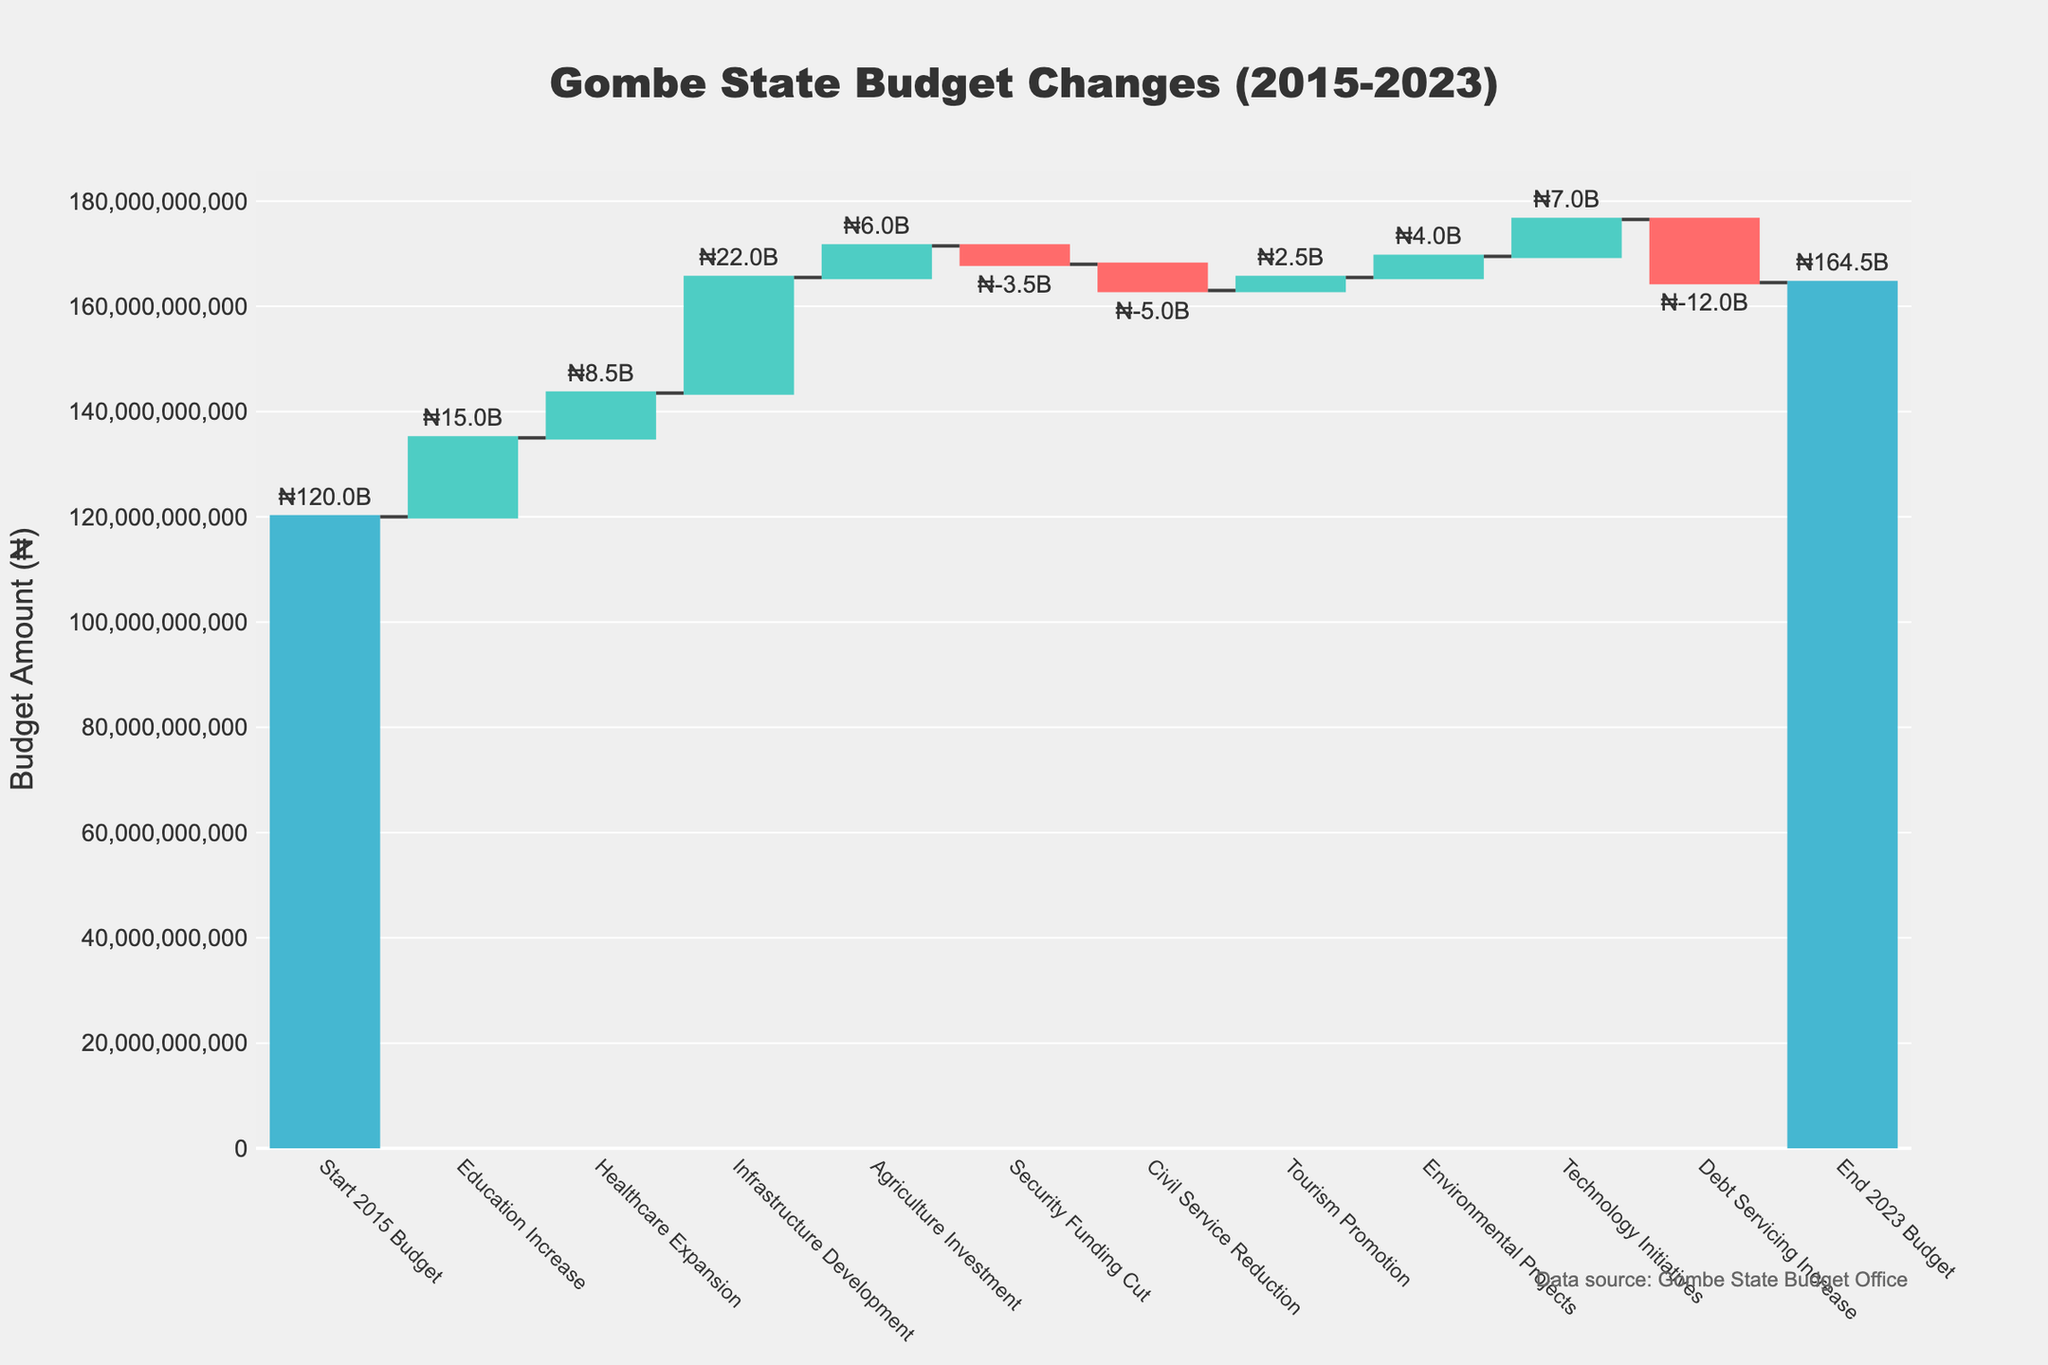What is the title of the chart? The title is typically located at the top of the chart and provides a summary of what the chart represents. In this case, by glancing at the top, we see "Gombe State Budget Changes (2015-2023)" as the title.
Answer: Gombe State Budget Changes (2015-2023) Which categories resulted in budget cuts? In a waterfall chart, categories that decrease the budget are usually in a distinct color. Here, categories such as "Security Funding Cut", "Civil Service Reduction", and "Debt Servicing Increase" are represented with a color indicating a decrease.
Answer: Security Funding Cut, Civil Service Reduction, Debt Servicing Increase By how much did the budget increase due to Infrastructure Development? To find the amount contributed by "Infrastructure Development", look at the corresponding bar's label. The label shows ₦22.0B as the increase from this category.
Answer: ₦22.0B What is the total budget at the end of 2023? The final bar in the waterfall chart often represents the total figure after all changes. Here, it is labeled "End 2023 Budget" with the value of ₦164.5B.
Answer: ₦164.5B How much was spent on Technology Initiatives? By locating the "Technology Initiatives" bar on the chart, we see that it resulted in an increase of ₦7.0B to the budget.
Answer: ₦7.0B Which category had the smallest decrease in the budget? By comparing the lengths of the decreasing bars and their labeled values, "Security Funding Cut" had the smallest decrease at ₦ -3.5B.
Answer: Security Funding Cut What is the net change in the budget between 2015 and 2023? Calculating net change involves summing all increases and decreases or comparing the start and end values. The net change is found by subtracting the 2015 Budget from the 2023 Budget: ₦164.5B - ₦120B = ₦44.5B.
Answer: ₦44.5B What was the initial budget in 2015? The first bar or category typically represents the starting value which here is labeled "Start 2015 Budget" with a value of ₦120B.
Answer: ₦120B How significant was the budget cut due to "Debt Servicing Increase" compared to the total budget at the end? The "Debt Servicing Increase" cut is ₦ -12.0B. To assess its significance, compare it with the ending budget: ₦12B / ₦164.5B ≈ 7.3%.
Answer: 7.3% Which category had the largest positive impact on the budget? By comparing the heights of increasing bars, "Infrastructure Development" had the largest impact with ₦22.0B.
Answer: Infrastructure Development 